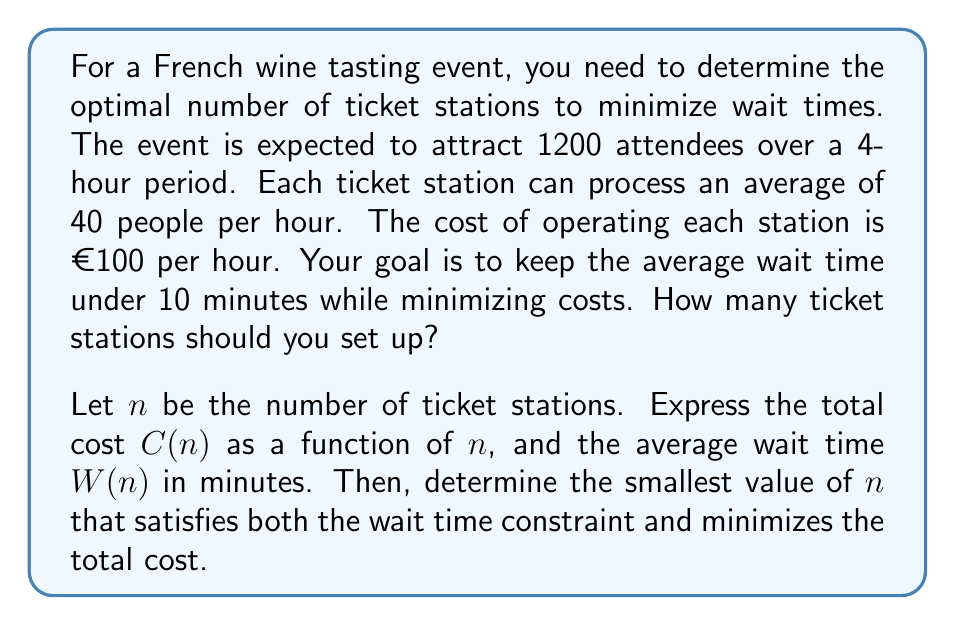Could you help me with this problem? Let's approach this step-by-step:

1) First, let's define our variables:
   $n$ = number of ticket stations
   $C(n)$ = total cost as a function of $n$
   $W(n)$ = average wait time in minutes as a function of $n$

2) Calculate the total cost function:
   Cost per station per hour = €100
   Number of hours = 4
   $C(n) = 100n \cdot 4 = 400n$

3) Calculate the average wait time function:
   Total attendees = 1200
   Total service capacity per hour = $40n$
   Average wait time in hours = $\frac{\text{Total attendees}}{\text{Total service capacity per hour}}$
   $W(n) = \frac{1200}{40n} \cdot 60 \text{ minutes} = \frac{1800}{n}$ minutes

4) Our constraints are:
   $W(n) \leq 10$ minutes (wait time constraint)
   Minimize $C(n)$ (cost minimization)

5) Solve the wait time constraint:
   $\frac{1800}{n} \leq 10$
   $1800 \leq 10n$
   $n \geq 180$

6) Since $n$ must be an integer and we want to minimize cost, we choose the smallest integer $n$ that satisfies this inequality:
   $n = 180$

7) Verify the cost:
   $C(180) = 400 \cdot 180 = €72,000$

Therefore, the optimal number of ticket stations is 180, which will result in an average wait time of exactly 10 minutes and a total cost of €72,000.
Answer: The optimal number of ticket stations is 180. 